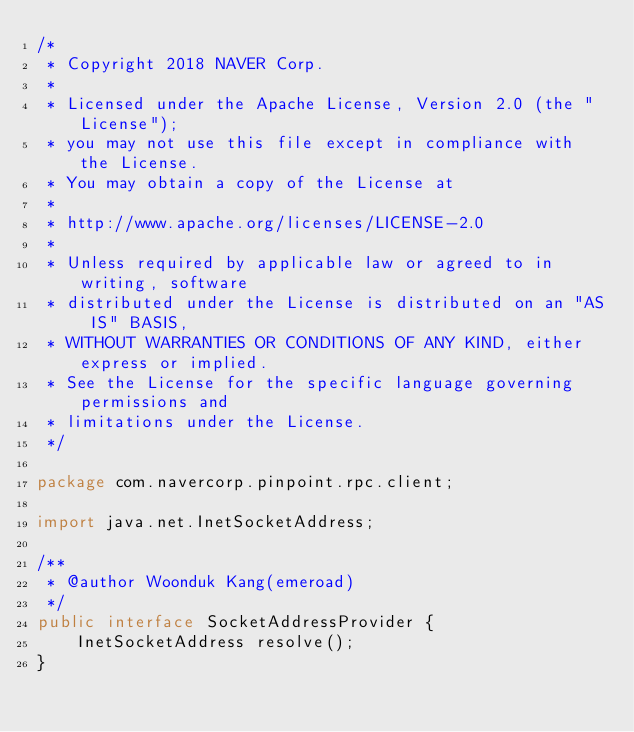Convert code to text. <code><loc_0><loc_0><loc_500><loc_500><_Java_>/*
 * Copyright 2018 NAVER Corp.
 *
 * Licensed under the Apache License, Version 2.0 (the "License");
 * you may not use this file except in compliance with the License.
 * You may obtain a copy of the License at
 *
 * http://www.apache.org/licenses/LICENSE-2.0
 *
 * Unless required by applicable law or agreed to in writing, software
 * distributed under the License is distributed on an "AS IS" BASIS,
 * WITHOUT WARRANTIES OR CONDITIONS OF ANY KIND, either express or implied.
 * See the License for the specific language governing permissions and
 * limitations under the License.
 */

package com.navercorp.pinpoint.rpc.client;

import java.net.InetSocketAddress;

/**
 * @author Woonduk Kang(emeroad)
 */
public interface SocketAddressProvider {
    InetSocketAddress resolve();
}
</code> 